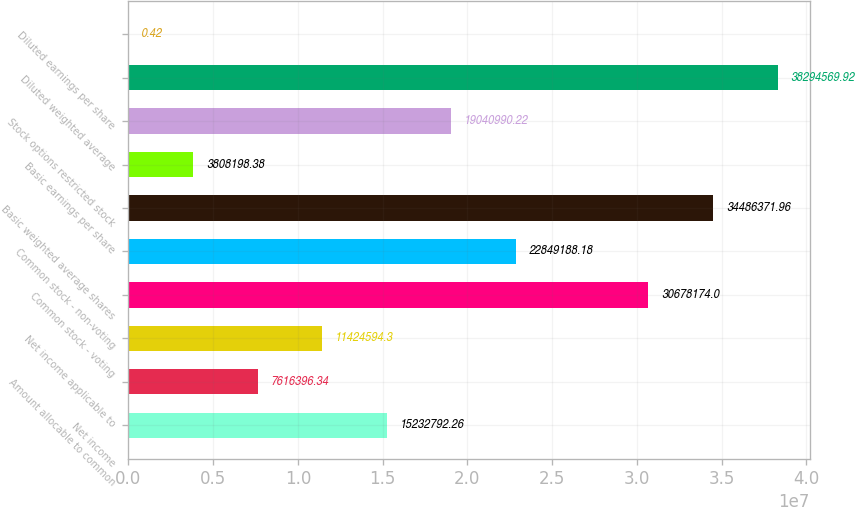Convert chart. <chart><loc_0><loc_0><loc_500><loc_500><bar_chart><fcel>Net income<fcel>Amount allocable to common<fcel>Net income applicable to<fcel>Common stock - voting<fcel>Common stock - non-voting<fcel>Basic weighted average shares<fcel>Basic earnings per share<fcel>Stock options restricted stock<fcel>Diluted weighted average<fcel>Diluted earnings per share<nl><fcel>1.52328e+07<fcel>7.6164e+06<fcel>1.14246e+07<fcel>3.06782e+07<fcel>2.28492e+07<fcel>3.44864e+07<fcel>3.8082e+06<fcel>1.9041e+07<fcel>3.82946e+07<fcel>0.42<nl></chart> 